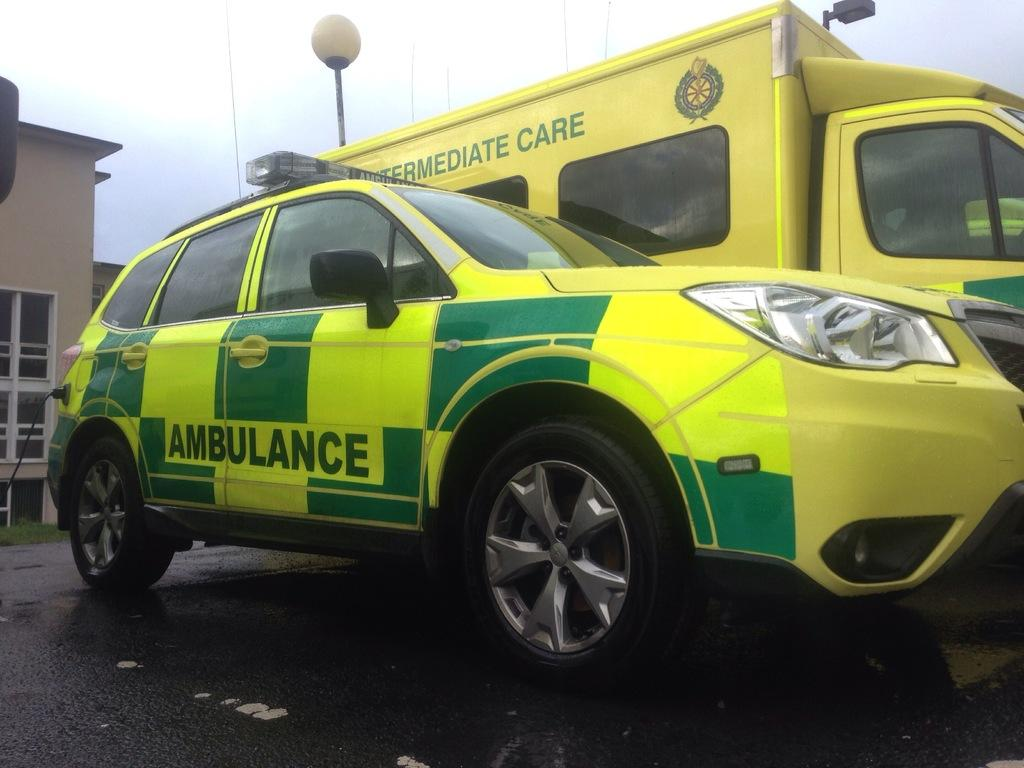<image>
Render a clear and concise summary of the photo. Ambulance and Paramedic vehicle that says Ambulance on the car and on truck it says Intermediate Care. 